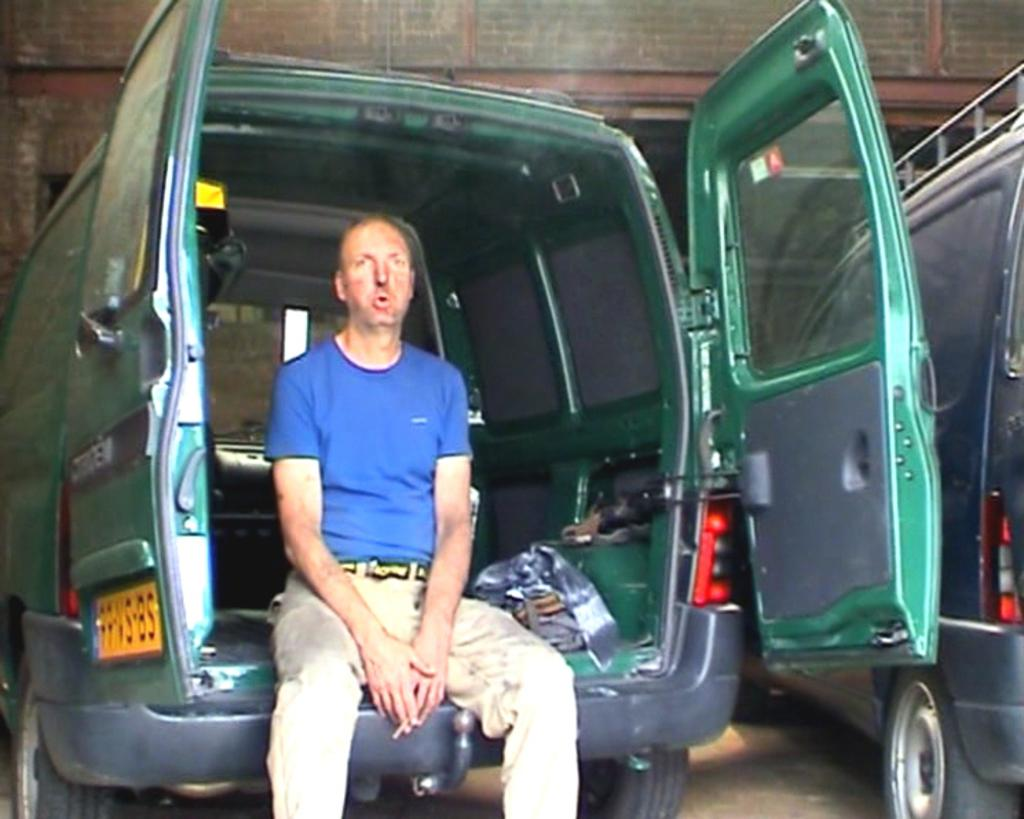Who is present in the image? There is a man in the image. What is the man doing in the image? The man is sitting on the backside the backside of a van. What is the state of the van's doors in the image? The doors of the van are open. What type of creature is sitting on the cabbage in the image? There is no creature or cabbage present in the image; it features a man sitting on the backside of a van with open doors. 